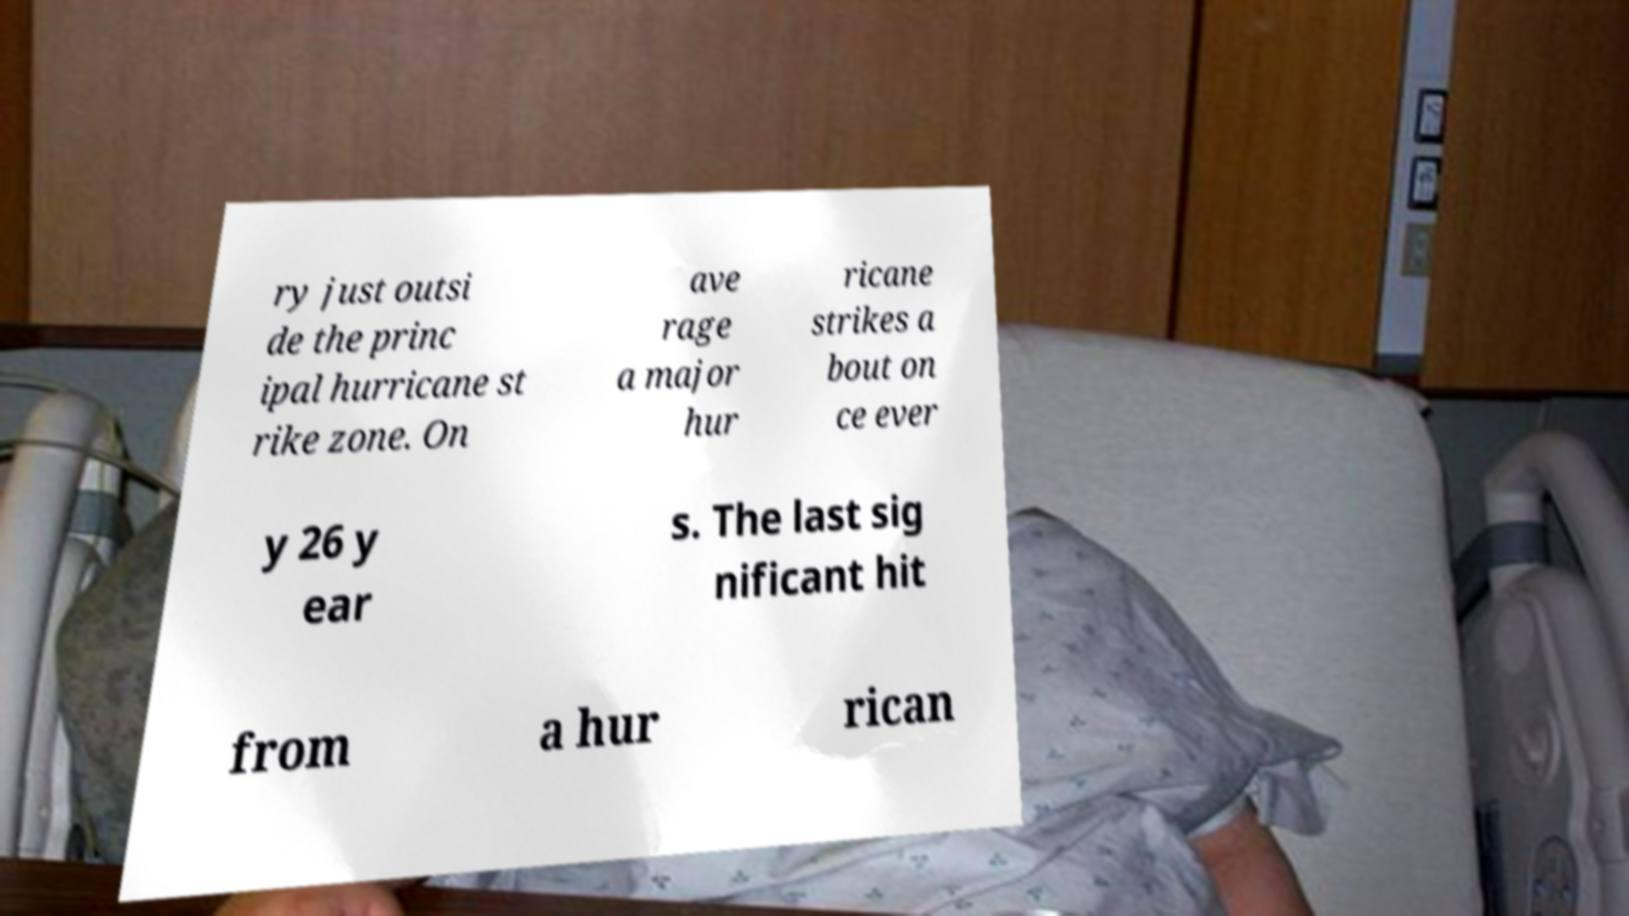Could you assist in decoding the text presented in this image and type it out clearly? ry just outsi de the princ ipal hurricane st rike zone. On ave rage a major hur ricane strikes a bout on ce ever y 26 y ear s. The last sig nificant hit from a hur rican 